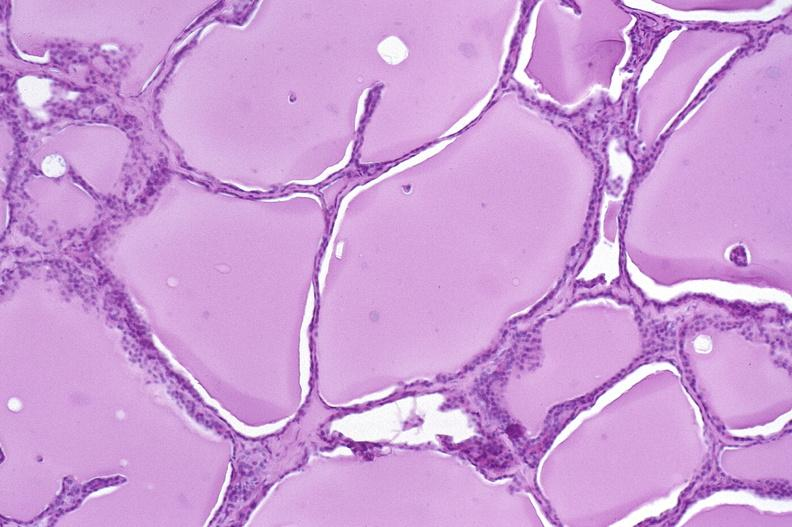s intraductal papillomatosis present?
Answer the question using a single word or phrase. No 